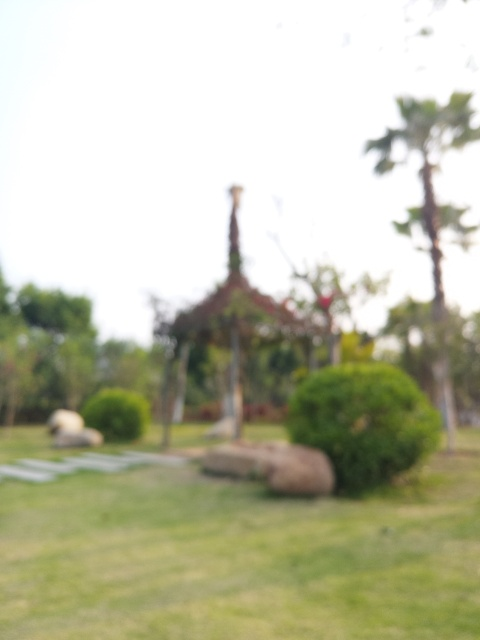Can you describe the setting or environment of this image? Although the image is blurry, we can distinguish a natural setting with elements like vegetation and what appears to be a styled structure, possibly a gazebo or garden feature, in the background. The lighting suggests it might be taken on a bright day outdoors. What could this place be used for? Based on the visible elements, even though they're not clear, this place could be a park or a garden. These areas are often used for relaxation, leisurely walks, picnics, and sometimes for events when they include structures like the one seen here. 